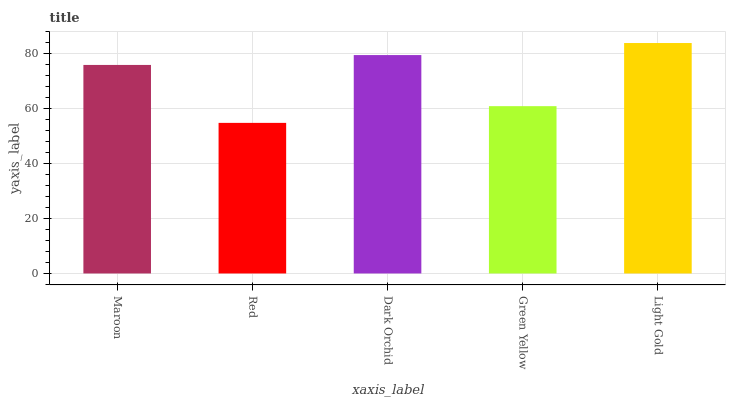Is Red the minimum?
Answer yes or no. Yes. Is Light Gold the maximum?
Answer yes or no. Yes. Is Dark Orchid the minimum?
Answer yes or no. No. Is Dark Orchid the maximum?
Answer yes or no. No. Is Dark Orchid greater than Red?
Answer yes or no. Yes. Is Red less than Dark Orchid?
Answer yes or no. Yes. Is Red greater than Dark Orchid?
Answer yes or no. No. Is Dark Orchid less than Red?
Answer yes or no. No. Is Maroon the high median?
Answer yes or no. Yes. Is Maroon the low median?
Answer yes or no. Yes. Is Dark Orchid the high median?
Answer yes or no. No. Is Red the low median?
Answer yes or no. No. 